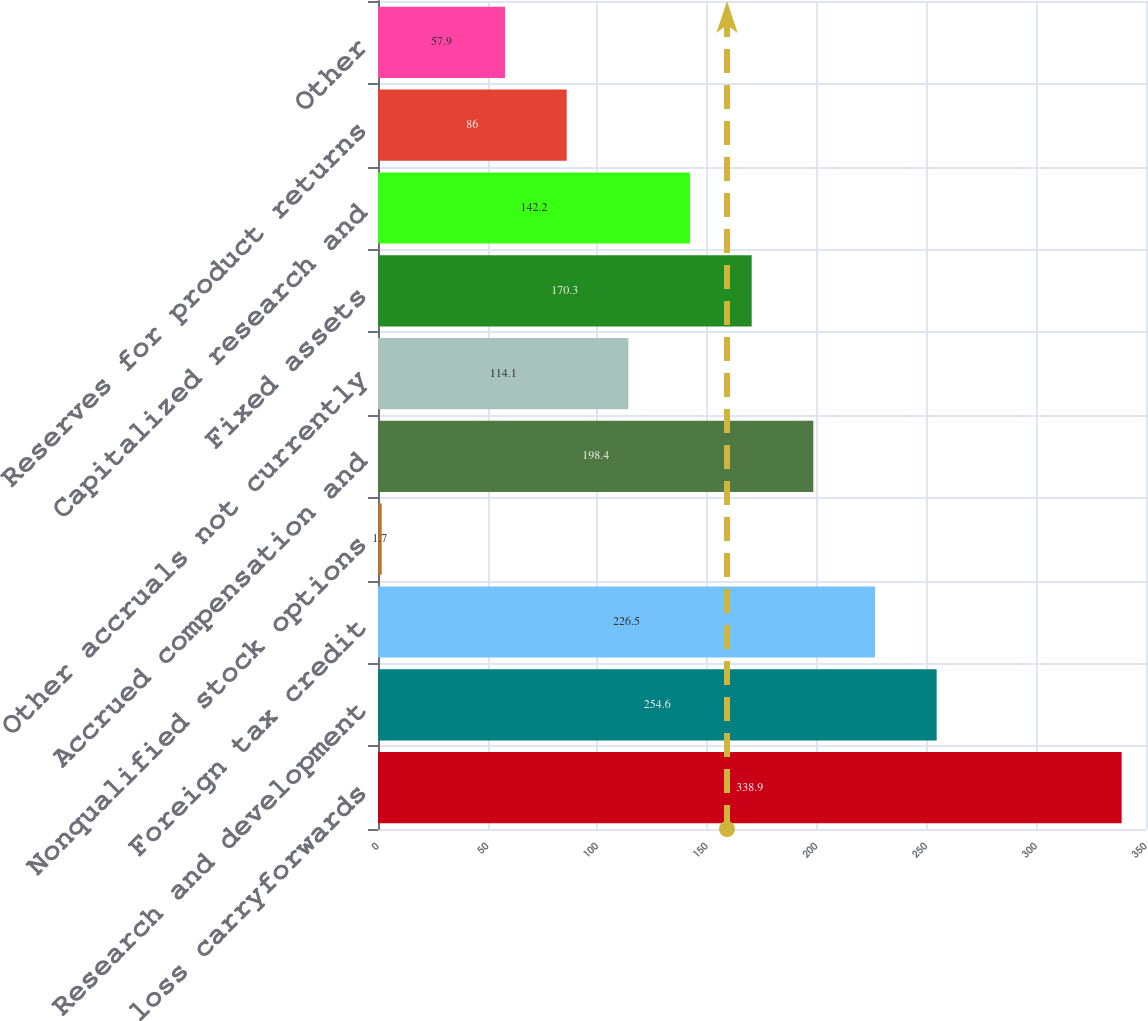<chart> <loc_0><loc_0><loc_500><loc_500><bar_chart><fcel>Tax loss carryforwards<fcel>Research and development<fcel>Foreign tax credit<fcel>Nonqualified stock options<fcel>Accrued compensation and<fcel>Other accruals not currently<fcel>Fixed assets<fcel>Capitalized research and<fcel>Reserves for product returns<fcel>Other<nl><fcel>338.9<fcel>254.6<fcel>226.5<fcel>1.7<fcel>198.4<fcel>114.1<fcel>170.3<fcel>142.2<fcel>86<fcel>57.9<nl></chart> 